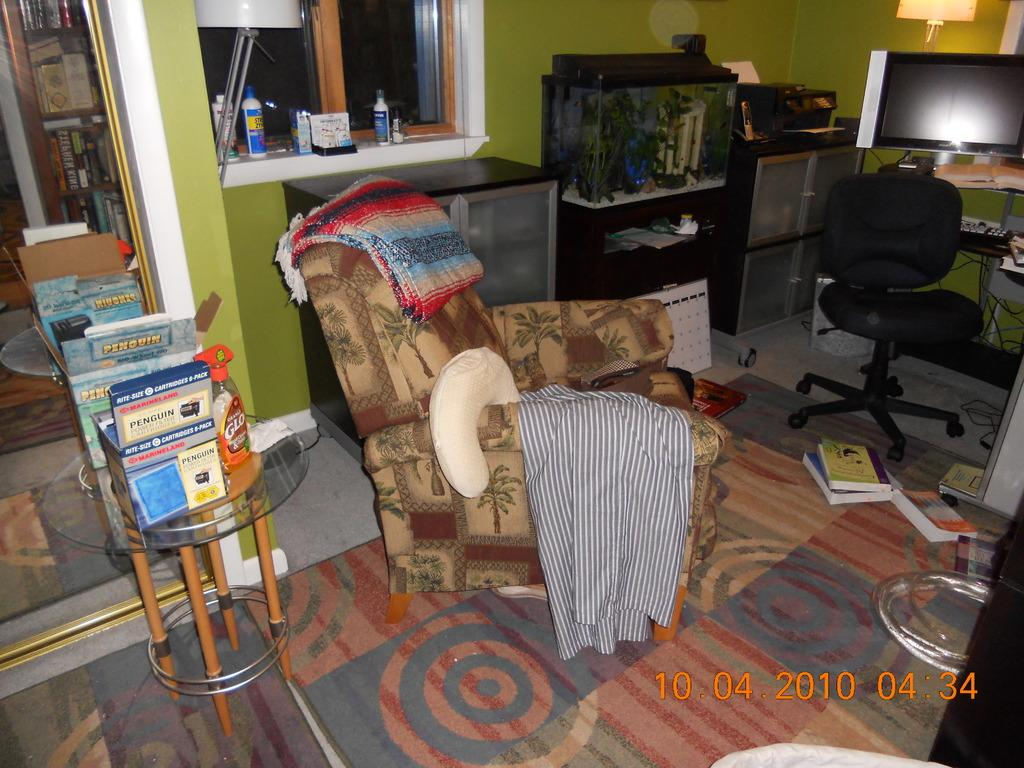<image>
Create a compact narrative representing the image presented. A slightly untidy room; on the left there are books, one of which has Penguin on the cover, 